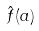<formula> <loc_0><loc_0><loc_500><loc_500>\hat { f } ( a )</formula> 